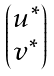Convert formula to latex. <formula><loc_0><loc_0><loc_500><loc_500>\begin{pmatrix} u ^ { \ast } \\ v ^ { \ast } \end{pmatrix}</formula> 